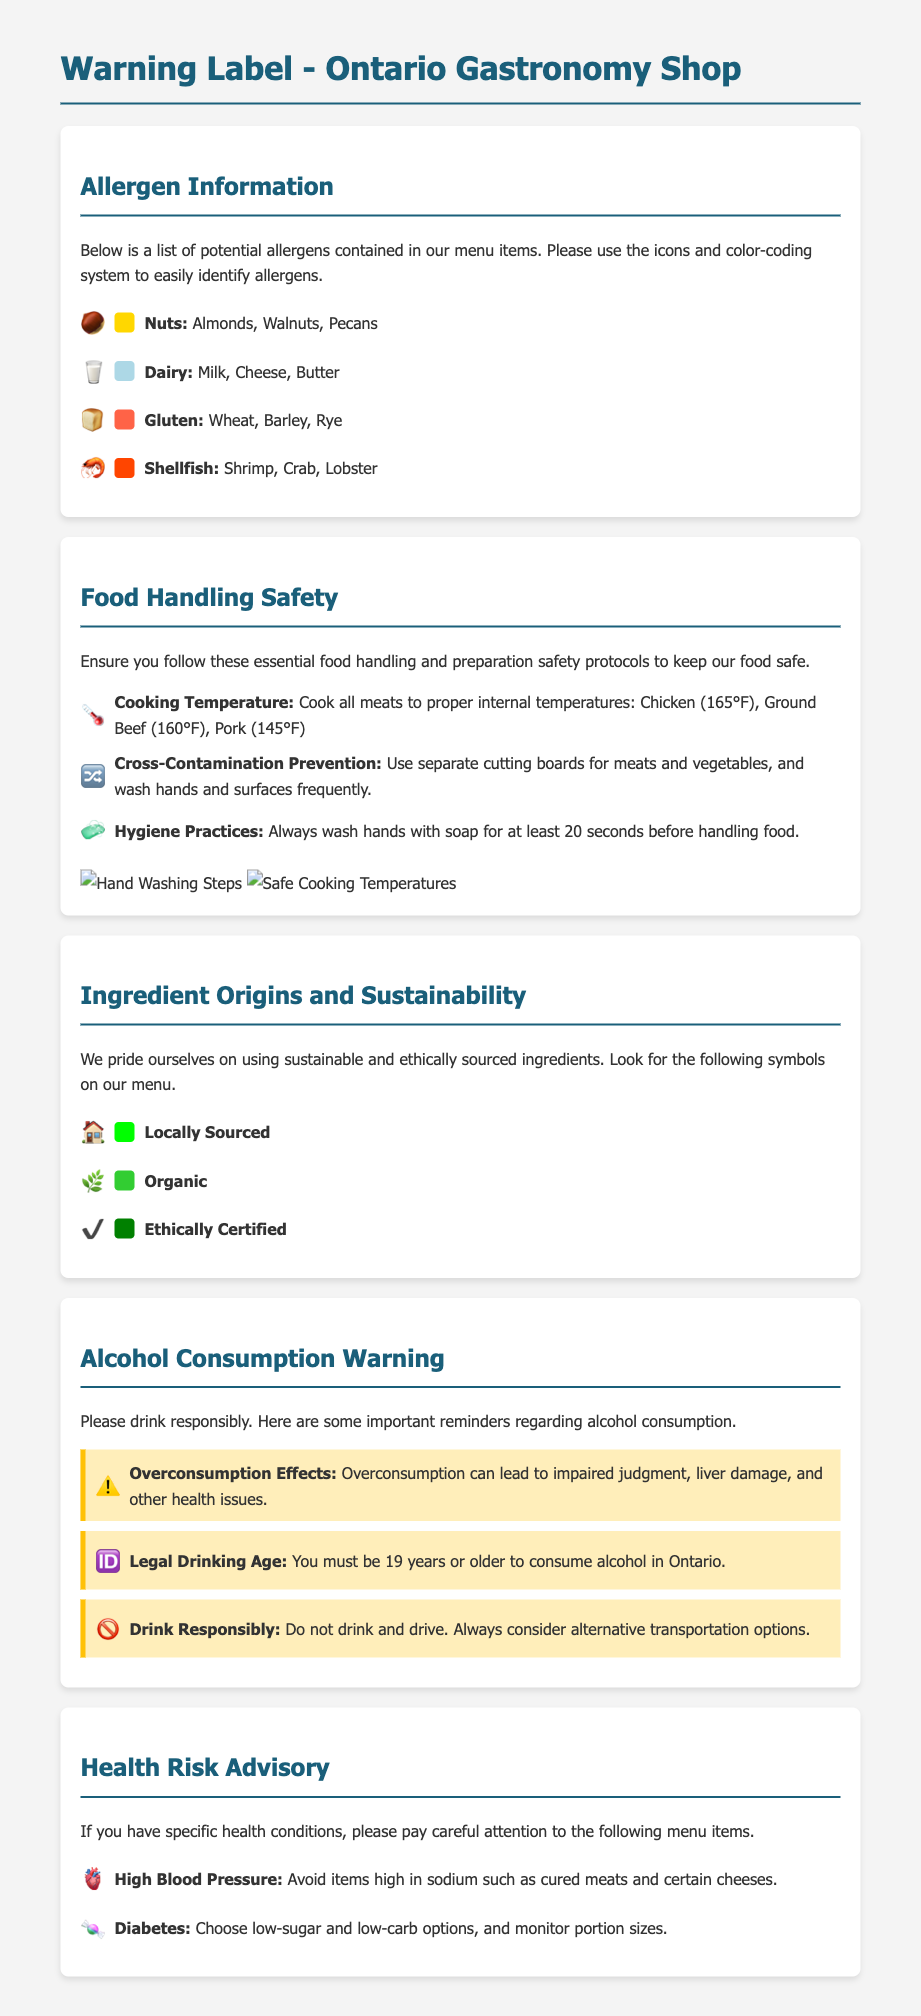What allergens are present in the menu items? The allergens listed in the document include nuts, dairy, gluten, and shellfish.
Answer: Nuts, dairy, gluten, shellfish What are the proper cooking temperatures for chicken? The document specifies that chicken should be cooked to an internal temperature of 165°F.
Answer: 165°F Which icon represents dairy allergens? The icon used for dairy allergens in the document is a milk emoji (🥛).
Answer: 🥛 How many health conditions are mentioned in the Health Risk Advisory section? The document mentions two specific health conditions: high blood pressure and diabetes.
Answer: Two What does the color green represent in the sustainability section? The green color is used to indicate items that are locally sourced.
Answer: Locally Sourced What should be avoided for high blood pressure according to the Health Risk Advisory? The document advises avoiding items high in sodium, such as cured meats.
Answer: Cured meats What is the legal drinking age in Ontario? The legal drinking age in Ontario, as stated in the document, is 19 years old.
Answer: 19 years What is the recommended hygiene practice before handling food? The document recommends washing hands with soap for at least 20 seconds before handling food.
Answer: 20 seconds 